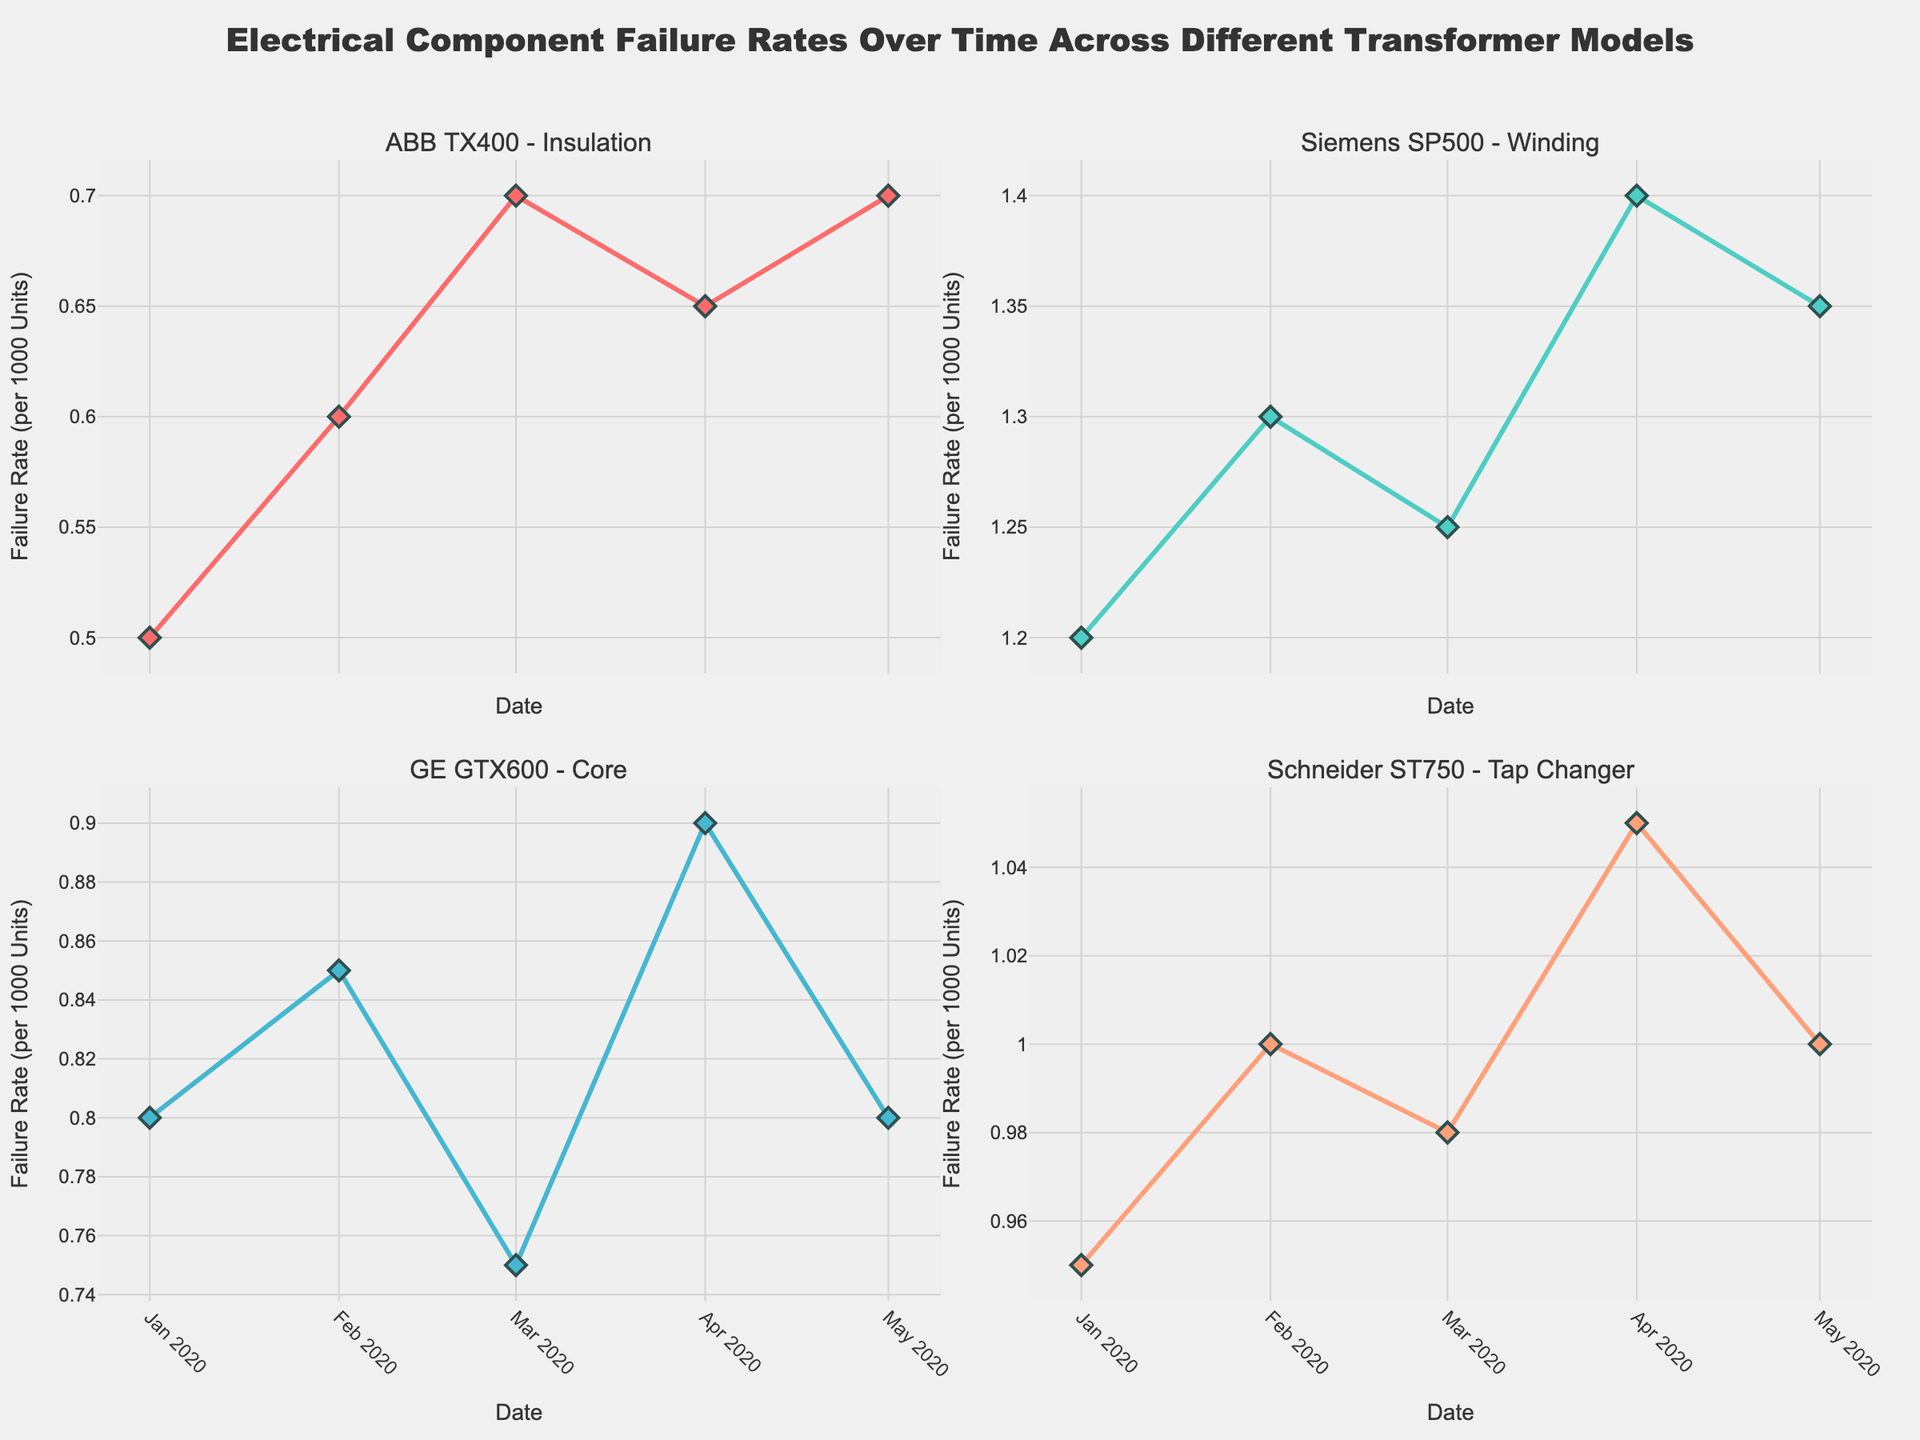Which transformer model has the highest initial failure rate? By examining the data points at the beginning of each subplot, the Siemens SP500 has the highest initial failure rate in January 2020.
Answer: Siemens SP500 How does the failure rate of the ABB TX400 insulation component change over time? The failure rate starts at 0.5 in January and gradually increases to 0.7 by March before slightly decreasing to 0.65 in April and rising again to 0.7 in May.
Answer: Increases, dips, then rises What is the average failure rate for the GE GTX600 core component over the displayed period? The failure rates are 0.8, 0.85, 0.75, 0.9, and 0.8. Summing these and dividing by 5 gives (0.8 + 0.85 + 0.75 + 0.9 + 0.8) / 5 = 0.82.
Answer: 0.82 Between April and May, which transformer model shows a noticeable decline in failure rate? Comparing the data points from April to May, the failure rate of the GE GTX600 decreases from 0.9 to 0.8.
Answer: GE GTX600 Which component shows an overall increasing trend in failure rate over the observed period? The Siemens SP500 winding component shows an overall increasing trend, with rates moving from 1.2 in January to 1.35 in May.
Answer: Siemens SP500 winding Which transformer model's failure rate remains constant between two consecutive months? The ABB TX400 shows a constant failure rate of 0.7 between March and May.
Answer: ABB TX400 How many transformer models demonstrate a failure rate higher than 1.0 at any point in the time series? Both Siemens SP500 and Schneider ST750 exceed a failure rate of 1.0 during the observed period.
Answer: 2 Which month shows the highest failure rate for the Schneider ST750 tap changer component? The failure rate for Schneider ST750 is highest in April at 1.05.
Answer: April For the Schneider ST750, how does the failure rate fluctuate from the beginning to the end of the time series? The failure rate increases from 0.95 in January to 1.0 in February, then dips slightly to 0.98 in March, rises to 1.05 in April, and returns to 1.0 in May.
Answer: Fluctuates up and down, then stabilizes 